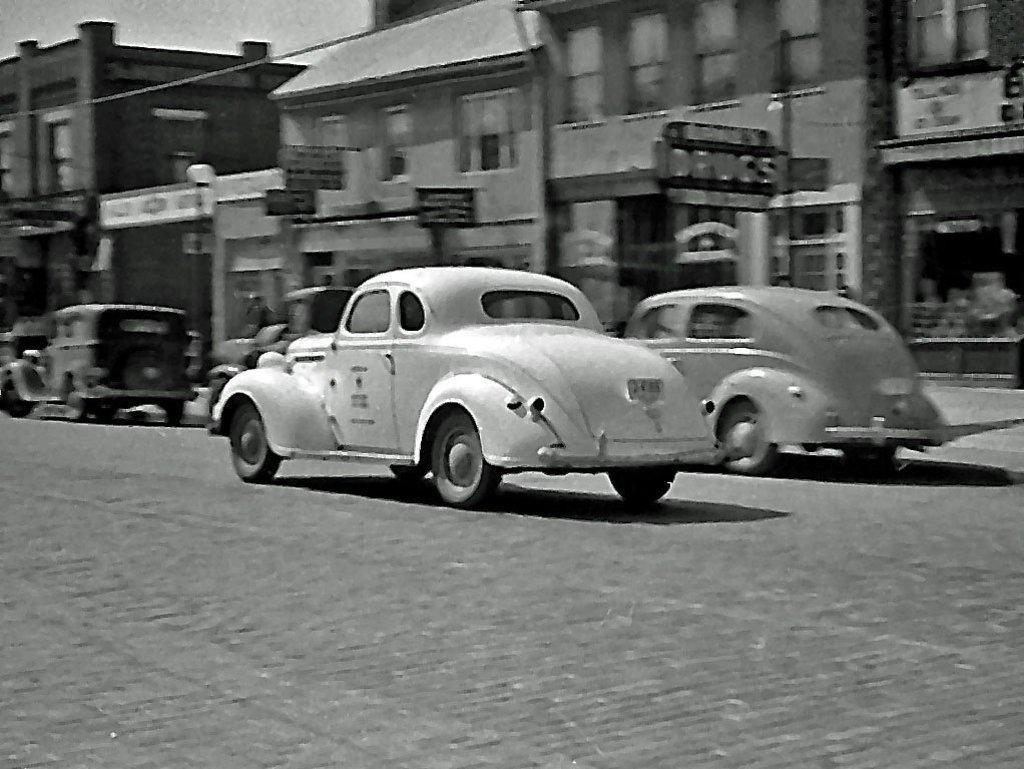Please provide a concise description of this image. This is a black and white image, in this image there are cars on a road, in the background there are buildings. 